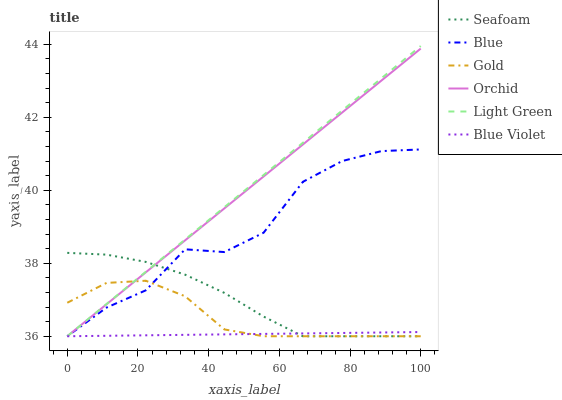Does Blue Violet have the minimum area under the curve?
Answer yes or no. Yes. Does Light Green have the maximum area under the curve?
Answer yes or no. Yes. Does Gold have the minimum area under the curve?
Answer yes or no. No. Does Gold have the maximum area under the curve?
Answer yes or no. No. Is Orchid the smoothest?
Answer yes or no. Yes. Is Blue the roughest?
Answer yes or no. Yes. Is Gold the smoothest?
Answer yes or no. No. Is Gold the roughest?
Answer yes or no. No. Does Blue have the lowest value?
Answer yes or no. Yes. Does Light Green have the highest value?
Answer yes or no. Yes. Does Gold have the highest value?
Answer yes or no. No. Does Blue Violet intersect Seafoam?
Answer yes or no. Yes. Is Blue Violet less than Seafoam?
Answer yes or no. No. Is Blue Violet greater than Seafoam?
Answer yes or no. No. 